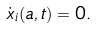Convert formula to latex. <formula><loc_0><loc_0><loc_500><loc_500>\dot { x } _ { i } ( a , t ) = 0 .</formula> 